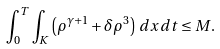Convert formula to latex. <formula><loc_0><loc_0><loc_500><loc_500>\int _ { 0 } ^ { T } \int _ { K } \left ( \rho ^ { \gamma + 1 } + \delta \rho ^ { 3 } \right ) \, d x \, d t \leq M .</formula> 